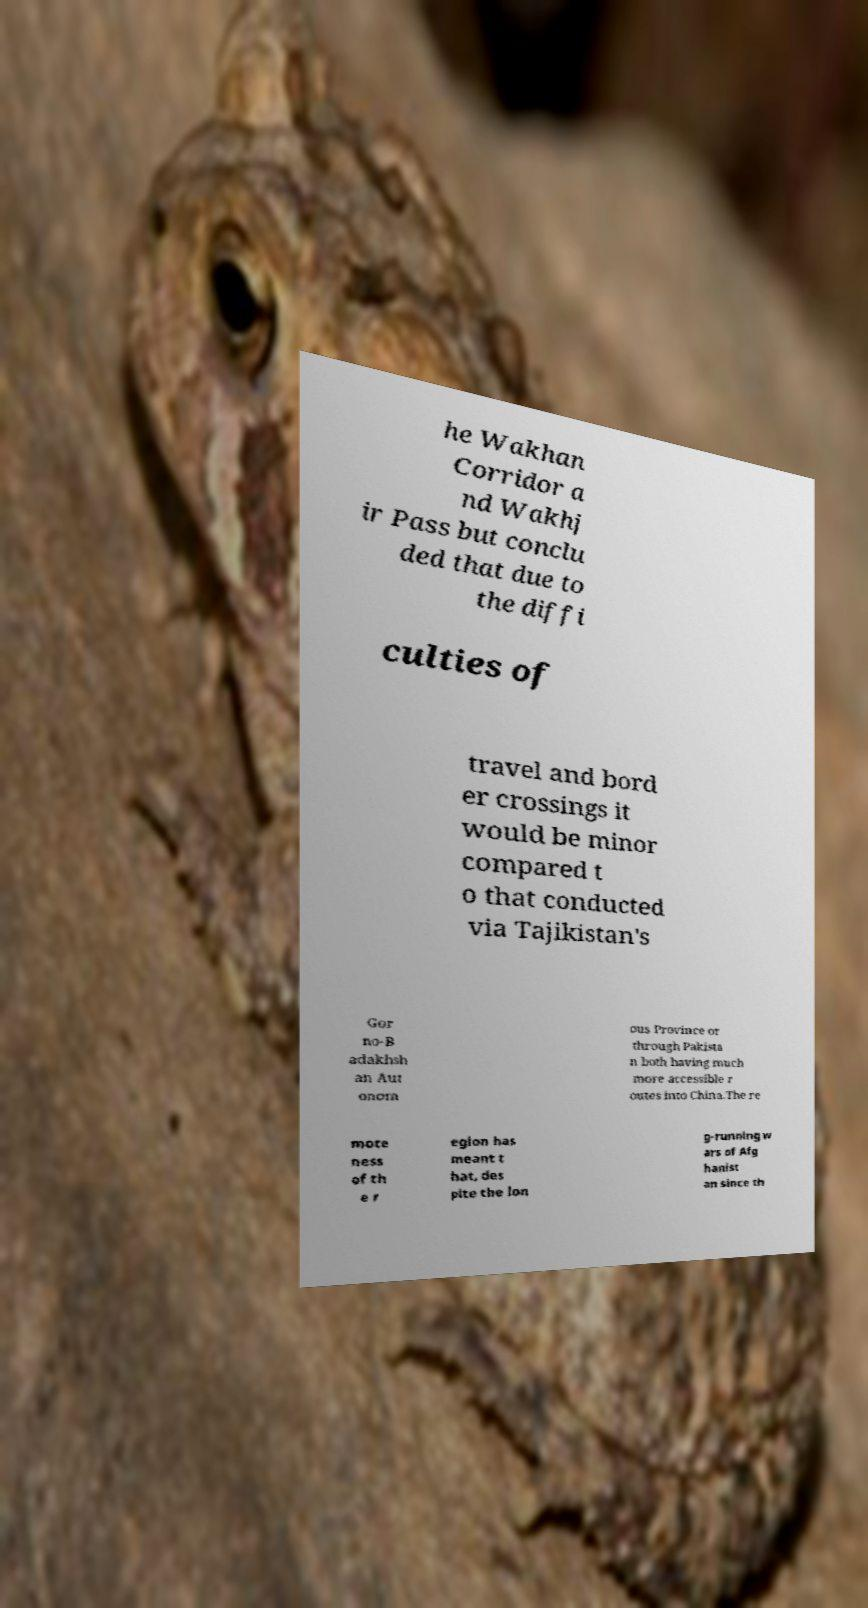I need the written content from this picture converted into text. Can you do that? he Wakhan Corridor a nd Wakhj ir Pass but conclu ded that due to the diffi culties of travel and bord er crossings it would be minor compared t o that conducted via Tajikistan's Gor no-B adakhsh an Aut onom ous Province or through Pakista n both having much more accessible r outes into China.The re mote ness of th e r egion has meant t hat, des pite the lon g-running w ars of Afg hanist an since th 